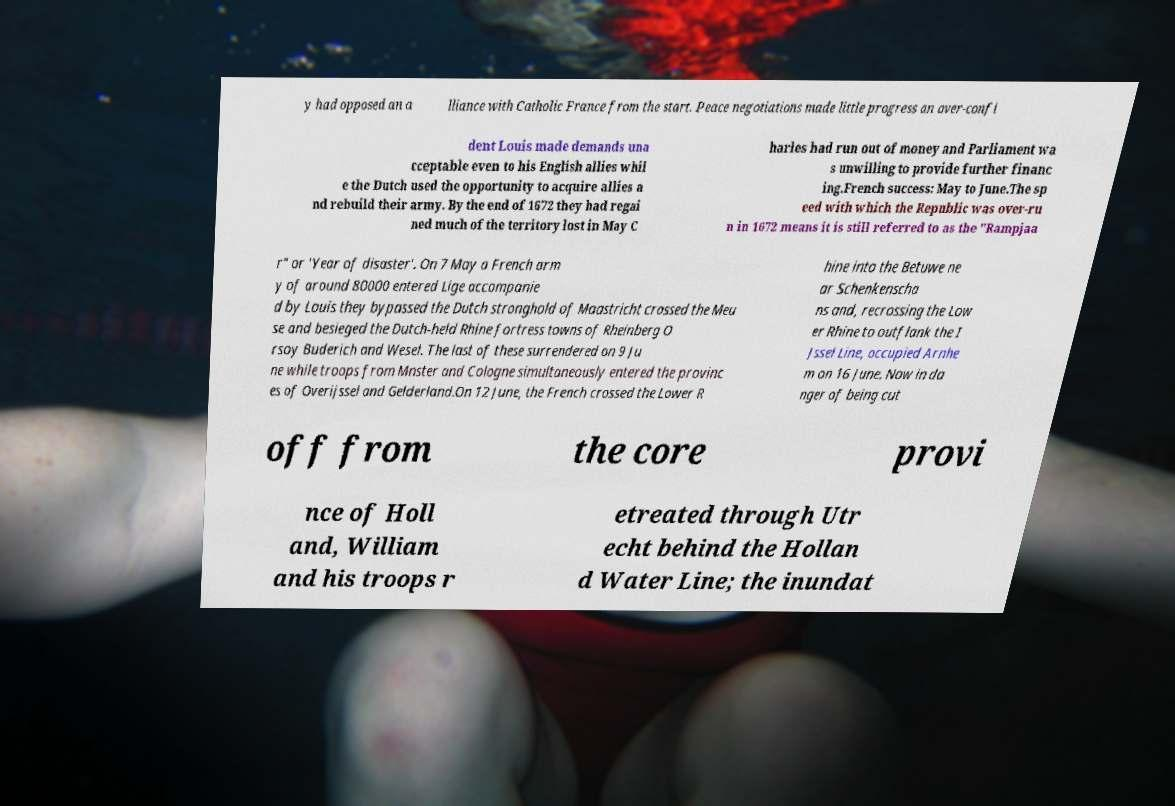Could you assist in decoding the text presented in this image and type it out clearly? y had opposed an a lliance with Catholic France from the start. Peace negotiations made little progress an over-confi dent Louis made demands una cceptable even to his English allies whil e the Dutch used the opportunity to acquire allies a nd rebuild their army. By the end of 1672 they had regai ned much of the territory lost in May C harles had run out of money and Parliament wa s unwilling to provide further financ ing.French success: May to June.The sp eed with which the Republic was over-ru n in 1672 means it is still referred to as the "Rampjaa r" or 'Year of disaster'. On 7 May a French arm y of around 80000 entered Lige accompanie d by Louis they bypassed the Dutch stronghold of Maastricht crossed the Meu se and besieged the Dutch-held Rhine fortress towns of Rheinberg O rsoy Buderich and Wesel. The last of these surrendered on 9 Ju ne while troops from Mnster and Cologne simultaneously entered the provinc es of Overijssel and Gelderland.On 12 June, the French crossed the Lower R hine into the Betuwe ne ar Schenkenscha ns and, recrossing the Low er Rhine to outflank the I Jssel Line, occupied Arnhe m on 16 June. Now in da nger of being cut off from the core provi nce of Holl and, William and his troops r etreated through Utr echt behind the Hollan d Water Line; the inundat 